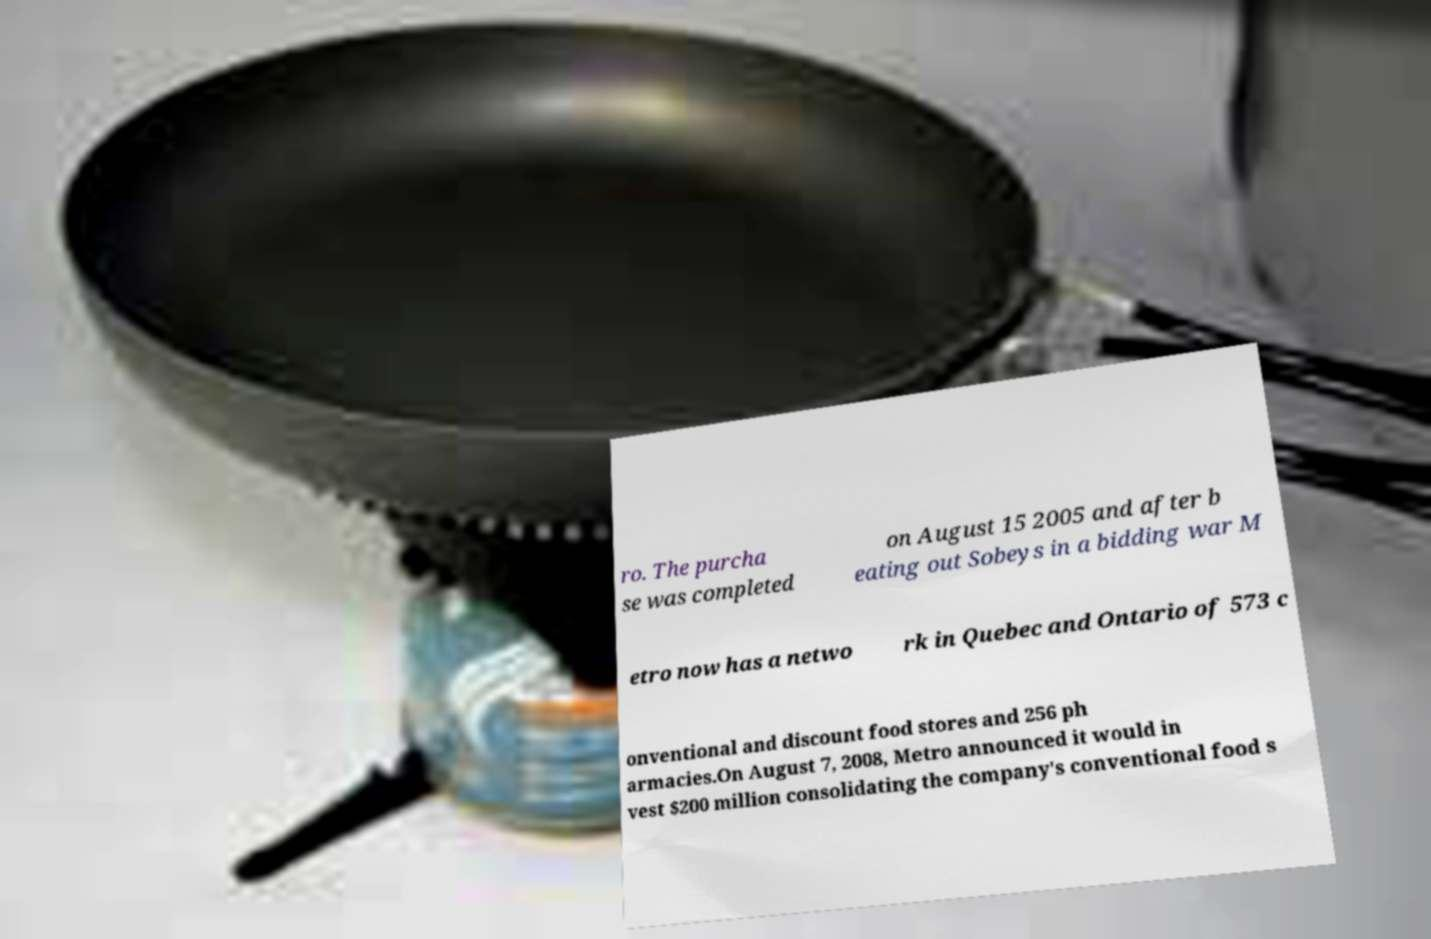I need the written content from this picture converted into text. Can you do that? ro. The purcha se was completed on August 15 2005 and after b eating out Sobeys in a bidding war M etro now has a netwo rk in Quebec and Ontario of 573 c onventional and discount food stores and 256 ph armacies.On August 7, 2008, Metro announced it would in vest $200 million consolidating the company's conventional food s 